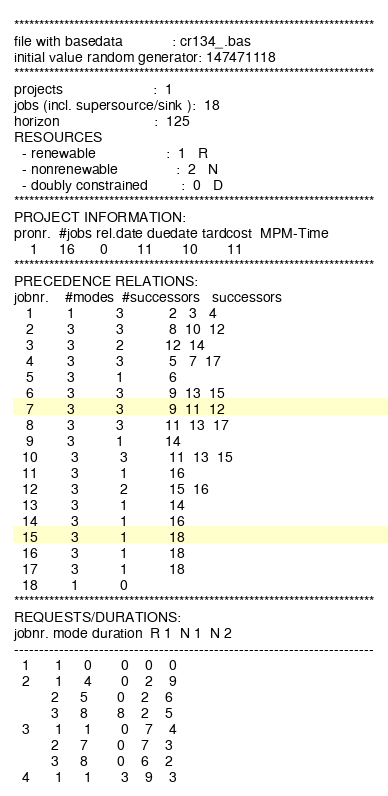Convert code to text. <code><loc_0><loc_0><loc_500><loc_500><_ObjectiveC_>************************************************************************
file with basedata            : cr134_.bas
initial value random generator: 147471118
************************************************************************
projects                      :  1
jobs (incl. supersource/sink ):  18
horizon                       :  125
RESOURCES
  - renewable                 :  1   R
  - nonrenewable              :  2   N
  - doubly constrained        :  0   D
************************************************************************
PROJECT INFORMATION:
pronr.  #jobs rel.date duedate tardcost  MPM-Time
    1     16      0       11       10       11
************************************************************************
PRECEDENCE RELATIONS:
jobnr.    #modes  #successors   successors
   1        1          3           2   3   4
   2        3          3           8  10  12
   3        3          2          12  14
   4        3          3           5   7  17
   5        3          1           6
   6        3          3           9  13  15
   7        3          3           9  11  12
   8        3          3          11  13  17
   9        3          1          14
  10        3          3          11  13  15
  11        3          1          16
  12        3          2          15  16
  13        3          1          14
  14        3          1          16
  15        3          1          18
  16        3          1          18
  17        3          1          18
  18        1          0        
************************************************************************
REQUESTS/DURATIONS:
jobnr. mode duration  R 1  N 1  N 2
------------------------------------------------------------------------
  1      1     0       0    0    0
  2      1     4       0    2    9
         2     5       0    2    6
         3     8       8    2    5
  3      1     1       0    7    4
         2     7       0    7    3
         3     8       0    6    2
  4      1     1       3    9    3</code> 